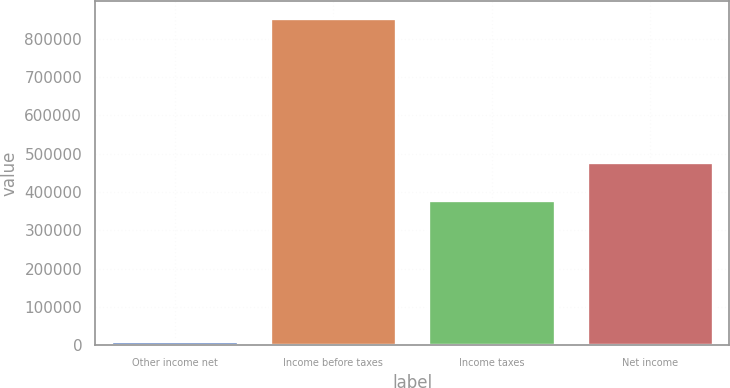Convert chart. <chart><loc_0><loc_0><loc_500><loc_500><bar_chart><fcel>Other income net<fcel>Income before taxes<fcel>Income taxes<fcel>Net income<nl><fcel>10962<fcel>855564<fcel>377949<fcel>477615<nl></chart> 